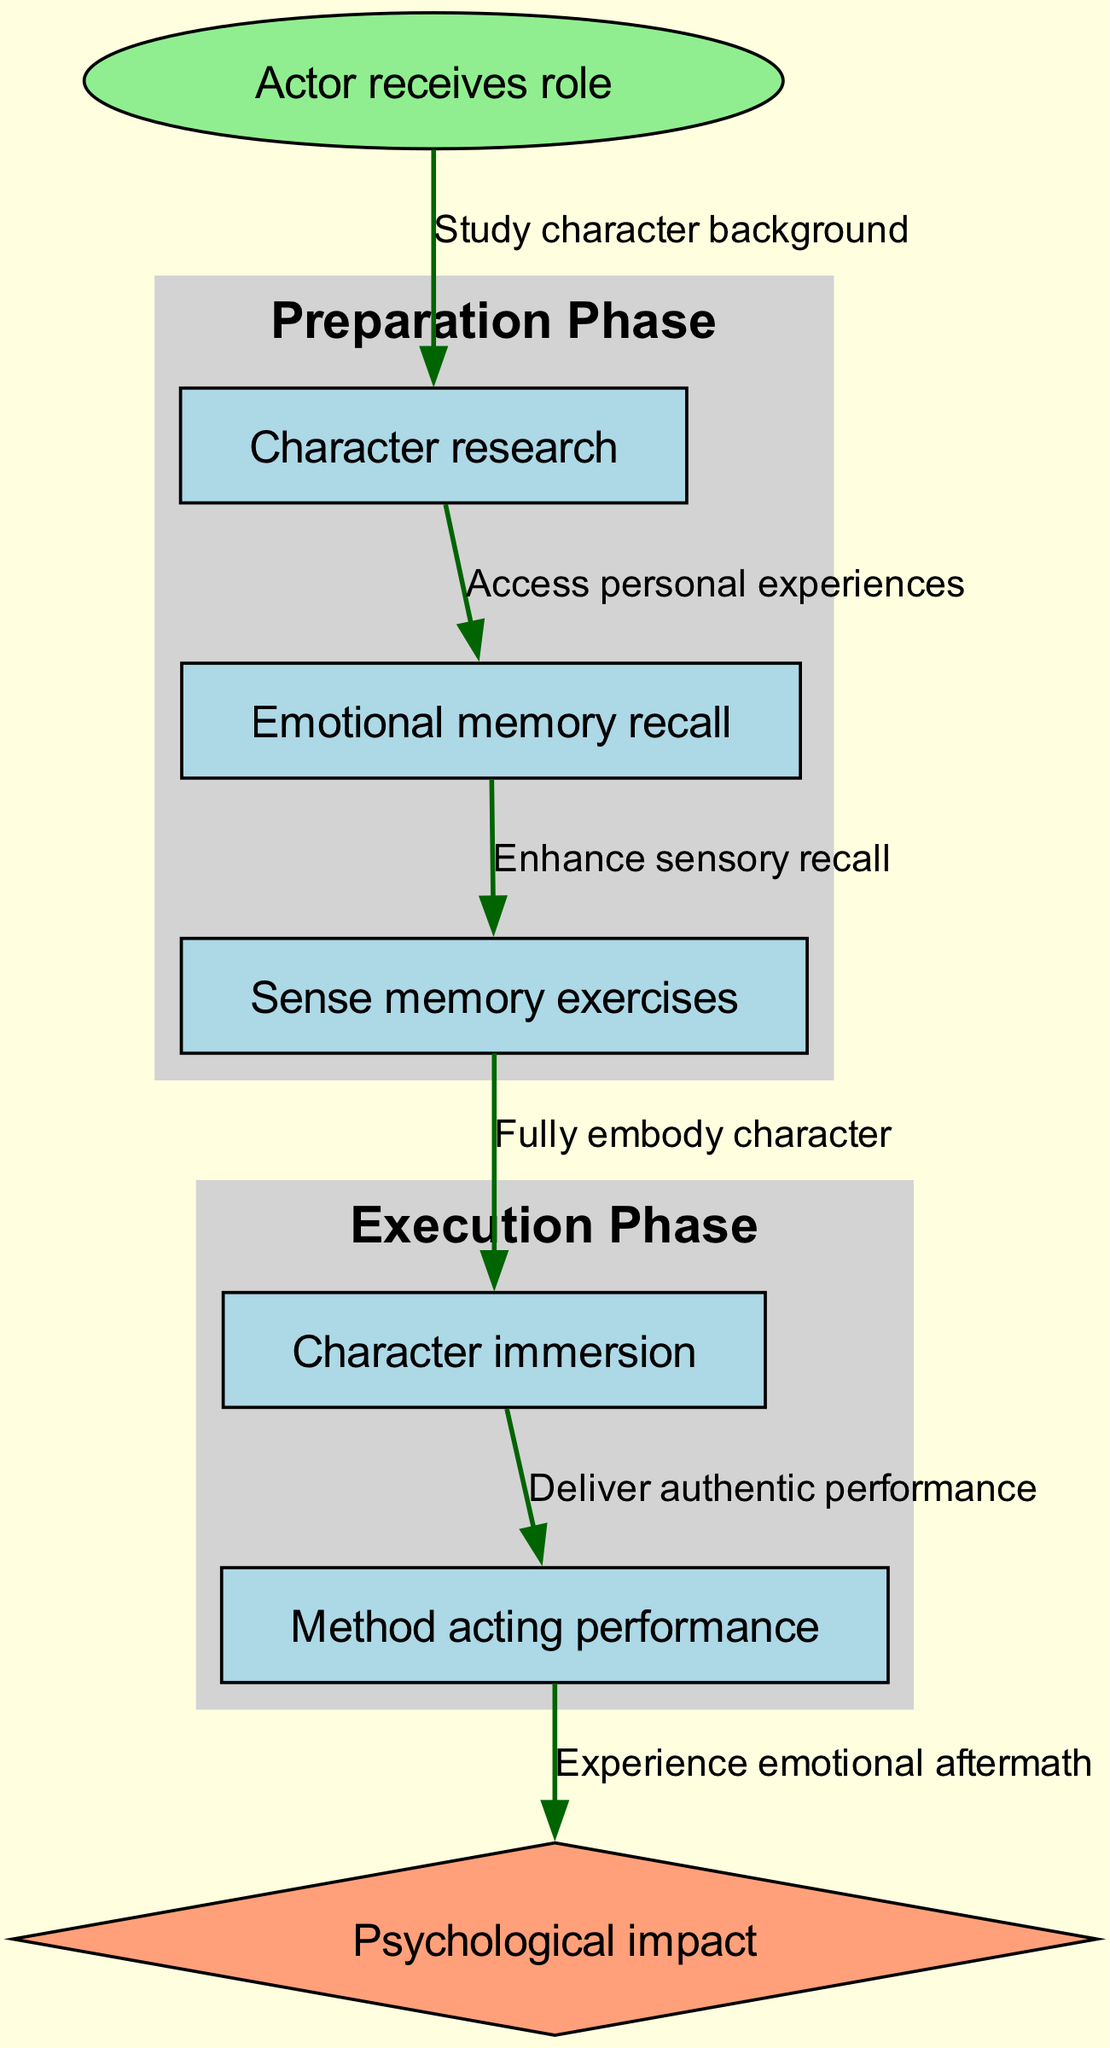What is the first step in the method acting process? The diagram shows that the process starts with the node labeled "Actor receives role." This indicates that the first step for the actor is to receive their role.
Answer: Actor receives role How many nodes are present in the diagram? By counting the nodes listed, we find there are seven unique nodes present in the diagram, which are: Actor receives role, Character research, Emotional memory recall, Sense memory exercises, Character immersion, Method acting performance, and Psychological impact.
Answer: 7 What connects "Emotional memory recall" to "Sense memory exercises"? In the diagram, there is a directed edge labeled "Enhance sensory recall" connecting the two nodes, indicating that the emotional memory recall leads directly into the sense memory exercises phase.
Answer: Enhance sensory recall What is the label of the last step in the flowchart? The last node in the flowchart before the psychological impact is labeled "Method acting performance," which represents the performance stage of method acting.
Answer: Method acting performance What are the two phases outlined in the diagram? The diagram contains two subgraphs labeled "Preparation Phase" and "Execution Phase." These phases group the related activities in the method acting process.
Answer: Preparation Phase, Execution Phase What is the psychological impact associated with? The diagram indicates that the node "Psychological impact" follows the "Method acting performance" node, meaning it is directly associated with the performance aspect of acting.
Answer: Method acting performance Which node enhances sensory recall? From the flow of the diagram, it is clear that "Emotional memory recall" is the node that connects to "Sense memory exercises," indicating that emotional memory recall enhances sensory recall.
Answer: Emotional memory recall 